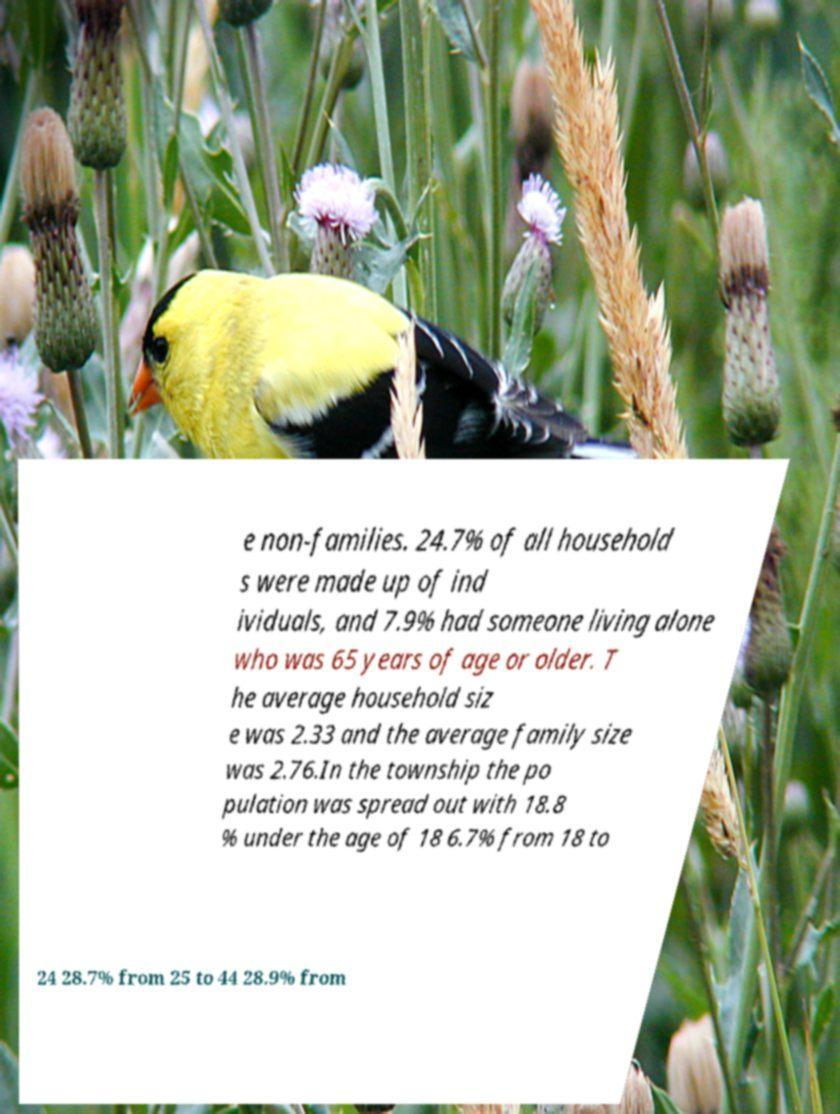Please read and relay the text visible in this image. What does it say? e non-families. 24.7% of all household s were made up of ind ividuals, and 7.9% had someone living alone who was 65 years of age or older. T he average household siz e was 2.33 and the average family size was 2.76.In the township the po pulation was spread out with 18.8 % under the age of 18 6.7% from 18 to 24 28.7% from 25 to 44 28.9% from 